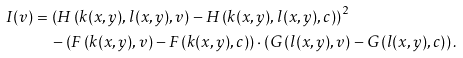<formula> <loc_0><loc_0><loc_500><loc_500>I ( v ) & = \left ( H \left ( k ( x , y ) , l ( x , y ) , v \right ) - H \left ( k ( x , y ) , l ( x , y ) , c \right ) \right ) ^ { 2 } \\ & \quad - \left ( F \left ( k ( x , y ) , v \right ) - F \left ( k ( x , y ) , c \right ) \right ) \cdot \left ( G \left ( l ( x , y ) , v \right ) - G \left ( l ( x , y ) , c \right ) \right ) .</formula> 